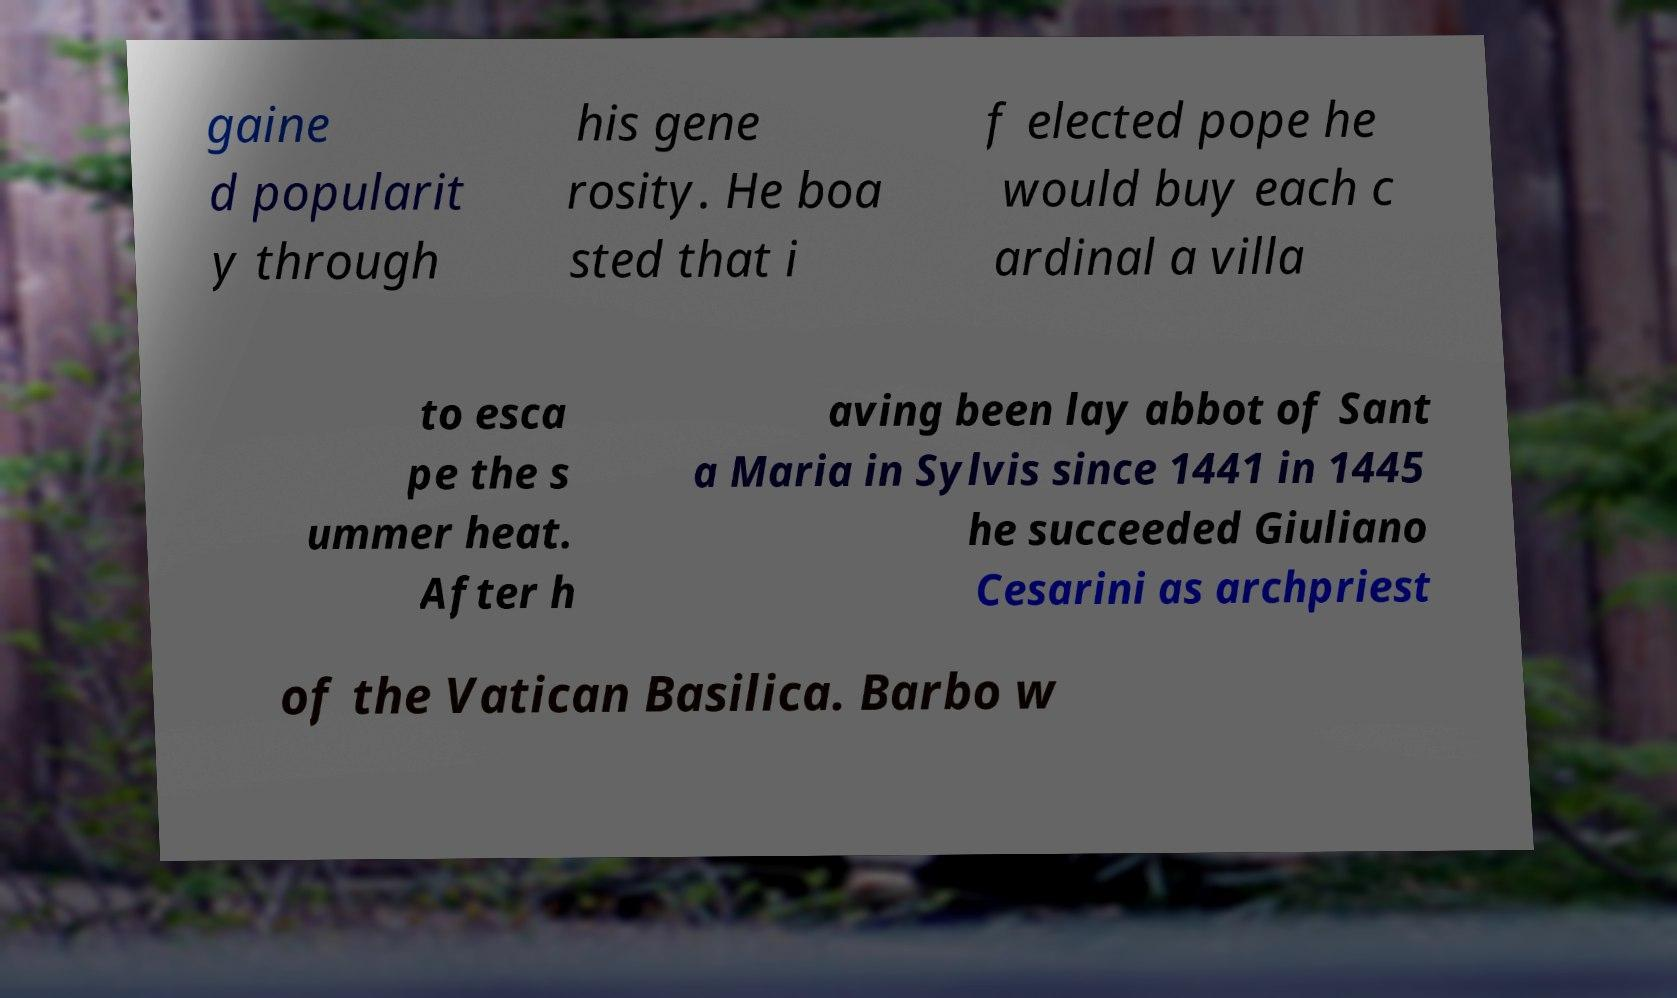Can you read and provide the text displayed in the image?This photo seems to have some interesting text. Can you extract and type it out for me? gaine d popularit y through his gene rosity. He boa sted that i f elected pope he would buy each c ardinal a villa to esca pe the s ummer heat. After h aving been lay abbot of Sant a Maria in Sylvis since 1441 in 1445 he succeeded Giuliano Cesarini as archpriest of the Vatican Basilica. Barbo w 